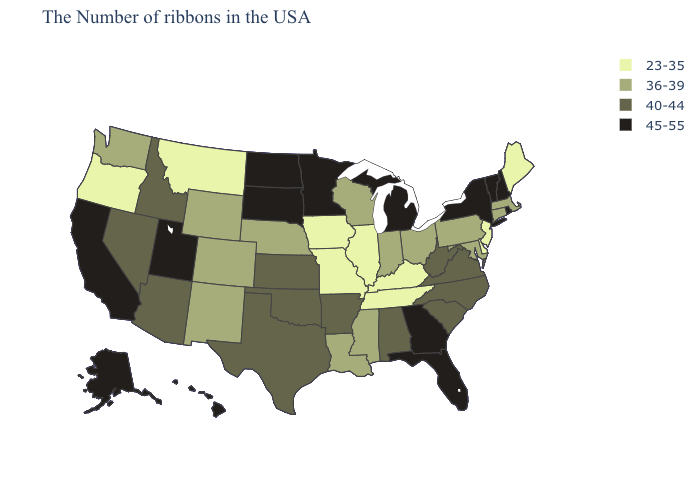Does Alabama have a lower value than Delaware?
Be succinct. No. What is the highest value in states that border Kansas?
Write a very short answer. 40-44. Does the map have missing data?
Keep it brief. No. What is the value of West Virginia?
Give a very brief answer. 40-44. Name the states that have a value in the range 23-35?
Be succinct. Maine, New Jersey, Delaware, Kentucky, Tennessee, Illinois, Missouri, Iowa, Montana, Oregon. What is the value of Tennessee?
Keep it brief. 23-35. Does Idaho have the same value as Minnesota?
Quick response, please. No. Which states have the lowest value in the USA?
Answer briefly. Maine, New Jersey, Delaware, Kentucky, Tennessee, Illinois, Missouri, Iowa, Montana, Oregon. Name the states that have a value in the range 36-39?
Keep it brief. Massachusetts, Connecticut, Maryland, Pennsylvania, Ohio, Indiana, Wisconsin, Mississippi, Louisiana, Nebraska, Wyoming, Colorado, New Mexico, Washington. What is the value of Idaho?
Keep it brief. 40-44. Name the states that have a value in the range 45-55?
Concise answer only. Rhode Island, New Hampshire, Vermont, New York, Florida, Georgia, Michigan, Minnesota, South Dakota, North Dakota, Utah, California, Alaska, Hawaii. Is the legend a continuous bar?
Quick response, please. No. Among the states that border Illinois , does Indiana have the lowest value?
Short answer required. No. Does Minnesota have a higher value than Louisiana?
Be succinct. Yes. Name the states that have a value in the range 45-55?
Concise answer only. Rhode Island, New Hampshire, Vermont, New York, Florida, Georgia, Michigan, Minnesota, South Dakota, North Dakota, Utah, California, Alaska, Hawaii. 